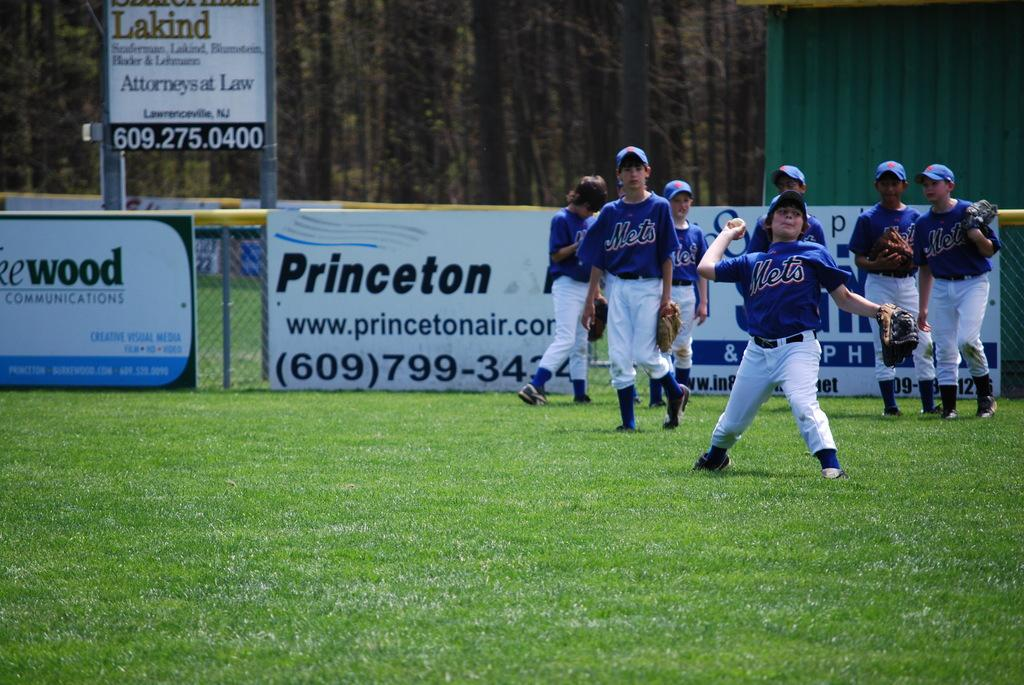Provide a one-sentence caption for the provided image. one of the sponsors of the baseball game is Princeton Air. 